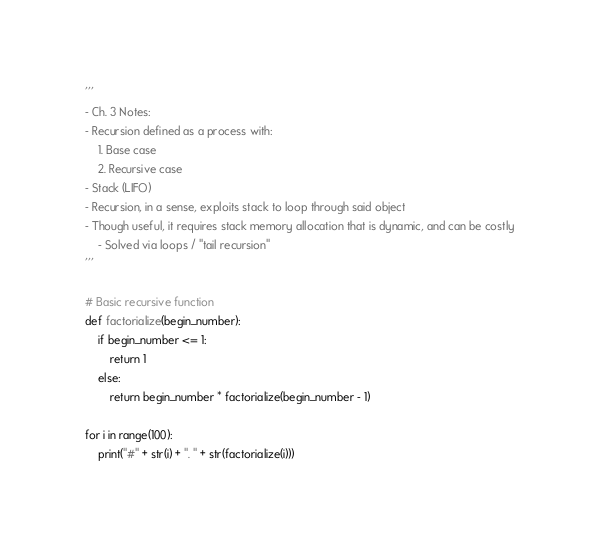Convert code to text. <code><loc_0><loc_0><loc_500><loc_500><_Python_>'''
- Ch. 3 Notes:
- Recursion defined as a process with:
    1. Base case
    2. Recursive case
- Stack (LIFO)
- Recursion, in a sense, exploits stack to loop through said object
- Though useful, it requires stack memory allocation that is dynamic, and can be costly
    - Solved via loops / "tail recursion"
'''

# Basic recursive function
def factorialize(begin_number):
    if begin_number <= 1:
        return 1
    else:
        return begin_number * factorialize(begin_number - 1)

for i in range(100):
    print("#" + str(i) + ". " + str(factorialize(i)))
</code> 